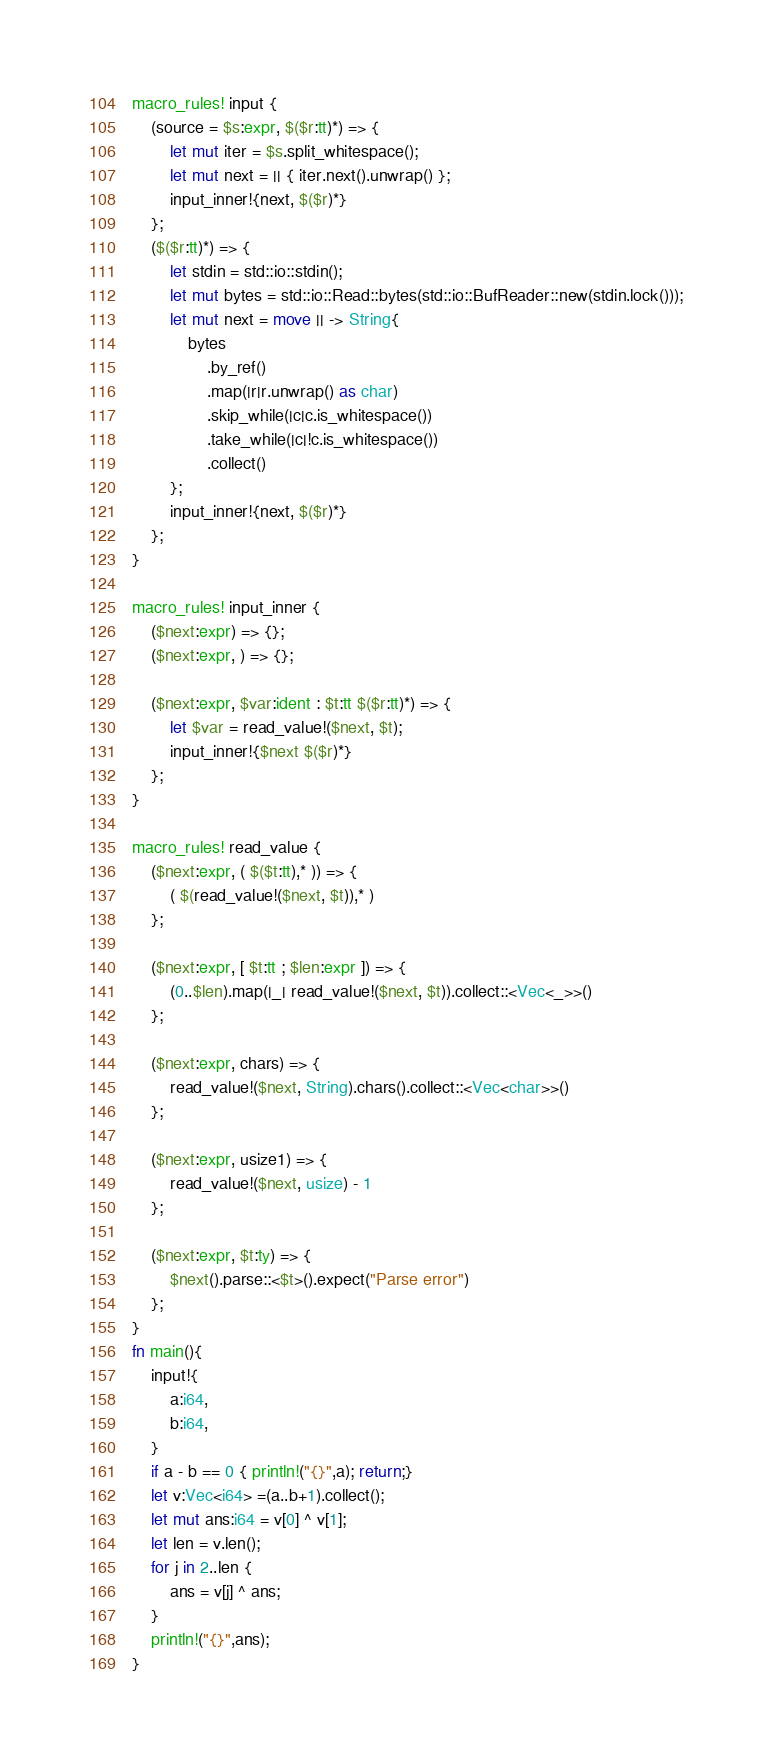<code> <loc_0><loc_0><loc_500><loc_500><_Rust_>macro_rules! input {
    (source = $s:expr, $($r:tt)*) => {
        let mut iter = $s.split_whitespace();
        let mut next = || { iter.next().unwrap() };
        input_inner!{next, $($r)*}
    };
    ($($r:tt)*) => {
        let stdin = std::io::stdin();
        let mut bytes = std::io::Read::bytes(std::io::BufReader::new(stdin.lock()));
        let mut next = move || -> String{
            bytes
                .by_ref()
                .map(|r|r.unwrap() as char)
                .skip_while(|c|c.is_whitespace())
                .take_while(|c|!c.is_whitespace())
                .collect()
        };
        input_inner!{next, $($r)*}
    };
}

macro_rules! input_inner {
    ($next:expr) => {};
    ($next:expr, ) => {};

    ($next:expr, $var:ident : $t:tt $($r:tt)*) => {
        let $var = read_value!($next, $t);
        input_inner!{$next $($r)*}
    };
}

macro_rules! read_value {
    ($next:expr, ( $($t:tt),* )) => {
        ( $(read_value!($next, $t)),* )
    };

    ($next:expr, [ $t:tt ; $len:expr ]) => {
        (0..$len).map(|_| read_value!($next, $t)).collect::<Vec<_>>()
    };

    ($next:expr, chars) => {
        read_value!($next, String).chars().collect::<Vec<char>>()
    };

    ($next:expr, usize1) => {
        read_value!($next, usize) - 1
    };

    ($next:expr, $t:ty) => {
        $next().parse::<$t>().expect("Parse error")
    };
}
fn main(){
    input!{
        a:i64,
        b:i64,
    }
    if a - b == 0 { println!("{}",a); return;}
    let v:Vec<i64> =(a..b+1).collect();
    let mut ans:i64 = v[0] ^ v[1];
    let len = v.len();
    for j in 2..len {
        ans = v[j] ^ ans;
    }
    println!("{}",ans);
}</code> 